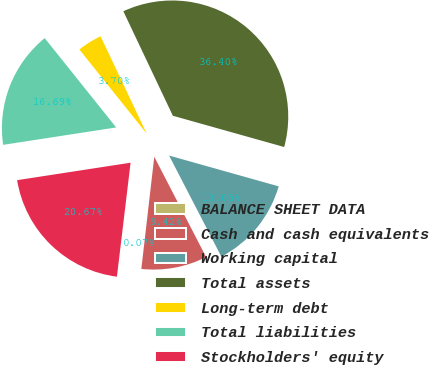<chart> <loc_0><loc_0><loc_500><loc_500><pie_chart><fcel>BALANCE SHEET DATA<fcel>Cash and cash equivalents<fcel>Working capital<fcel>Total assets<fcel>Long-term debt<fcel>Total liabilities<fcel>Stockholders' equity<nl><fcel>0.07%<fcel>9.42%<fcel>13.05%<fcel>36.4%<fcel>3.7%<fcel>16.69%<fcel>20.67%<nl></chart> 